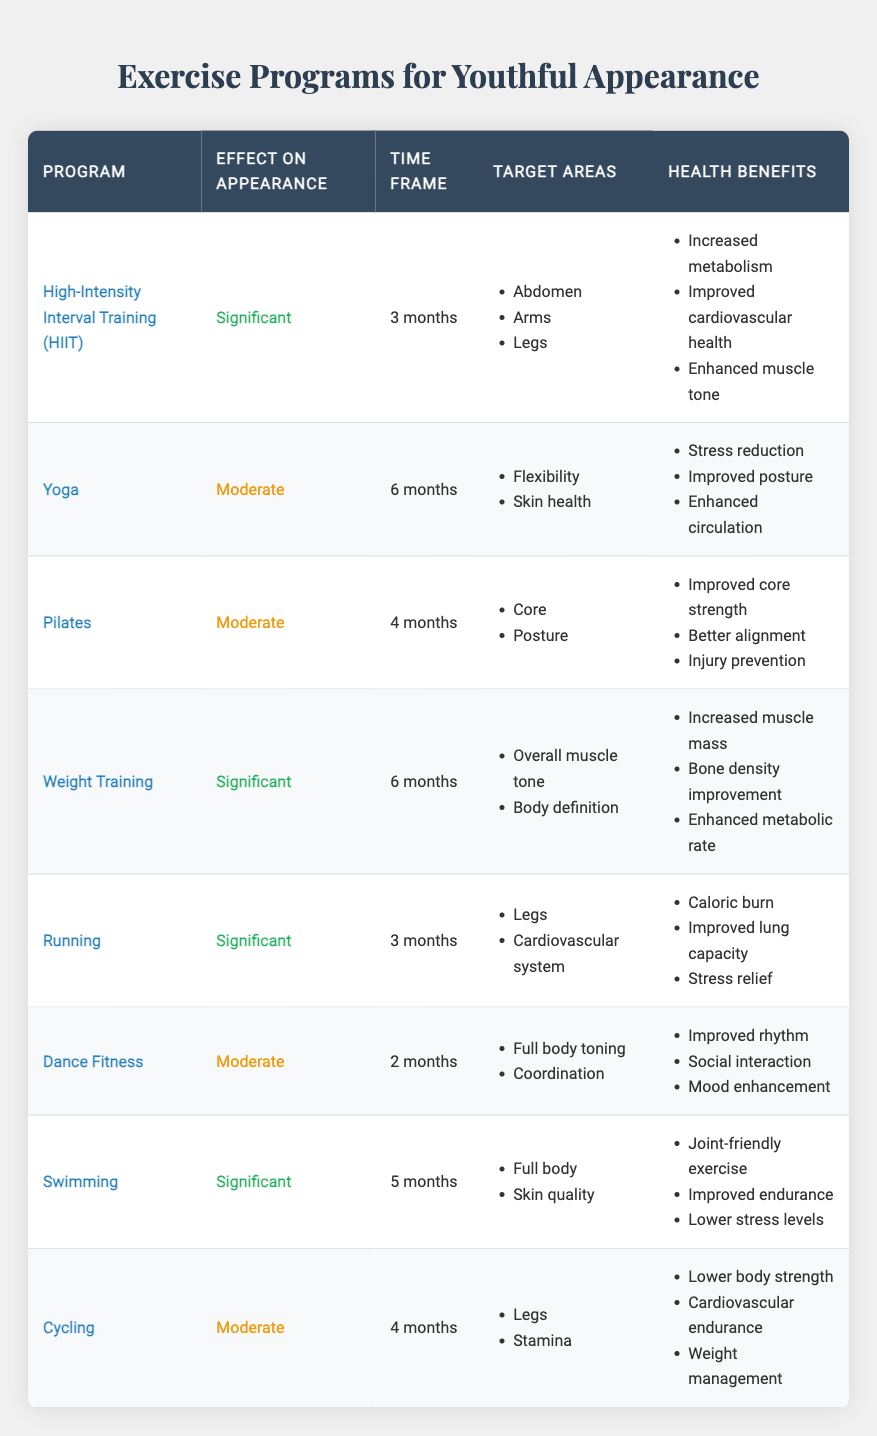What is the time frame for High-Intensity Interval Training (HIIT)? HIIT is listed in the table under the "Time Frame" column as having a duration of "3 months."
Answer: 3 months Which exercise program has a significant effect on appearance and targets the legs? The exercise programs listed with a significant effect on appearance are HIIT, Running, and Swimming. Out of these, Running specifically targets the legs.
Answer: Running Is Yoga effective for improving skin health? Yes, Yoga is noted in the table as having a moderate effect on appearance, and its target areas include "Skin health."
Answer: Yes What is the average time frame for the exercise programs that have a significant effect on appearance? The significant programs and their respective time frames are: HIIT (3 months), Weight Training (6 months), Running (3 months), and Swimming (5 months). To find the average: (3 + 6 + 3 + 5) / 4 = 17 / 4 = 4.25 months.
Answer: 4.25 months Which exercise program offers the most health benefits, and what are those benefits? Weight Training has three health benefits listed: "Increased muscle mass," "Bone density improvement," and "Enhanced metabolic rate." No other program has more than three benefits listed.
Answer: Weight Training; Increased muscle mass, Bone density improvement, Enhanced metabolic rate Does any program target full body toning in less than 3 months? No, Dance Fitness targets full body toning but has a duration of "2 months," which is less than 3 months, but it has a moderate effect on appearance. No program with significant effects targets full body toning in less than 3 months.
Answer: No What are the common target areas for programs with moderate effects on appearance? There are three programs with moderate effects: Yoga (Flexibility, Skin health), Pilates (Core, Posture), and Cycling (Legs, Stamina). Common target areas are not present, as each program has different focuses.
Answer: None Which program has the same effect on appearance as Pilates but has a shorter time frame? Pilates has a moderate effect and a time frame of 4 months. Dance Fitness has a moderate effect and a shorter time frame of 2 months. Thus, Dance Fitness is the answer.
Answer: Dance Fitness What key health benefits does Swimming provide? Swimming offers three key health benefits: "Joint-friendly exercise," "Improved endurance," and "Lower stress levels," as noted in the health benefits column of the Swimming row.
Answer: Joint-friendly exercise, Improved endurance, Lower stress levels 